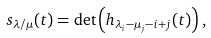Convert formula to latex. <formula><loc_0><loc_0><loc_500><loc_500>s _ { \lambda / \mu } ( { t } ) = \det \left ( h _ { \lambda _ { i } - \mu _ { j } - i + j } ( { t } ) \right ) ,</formula> 